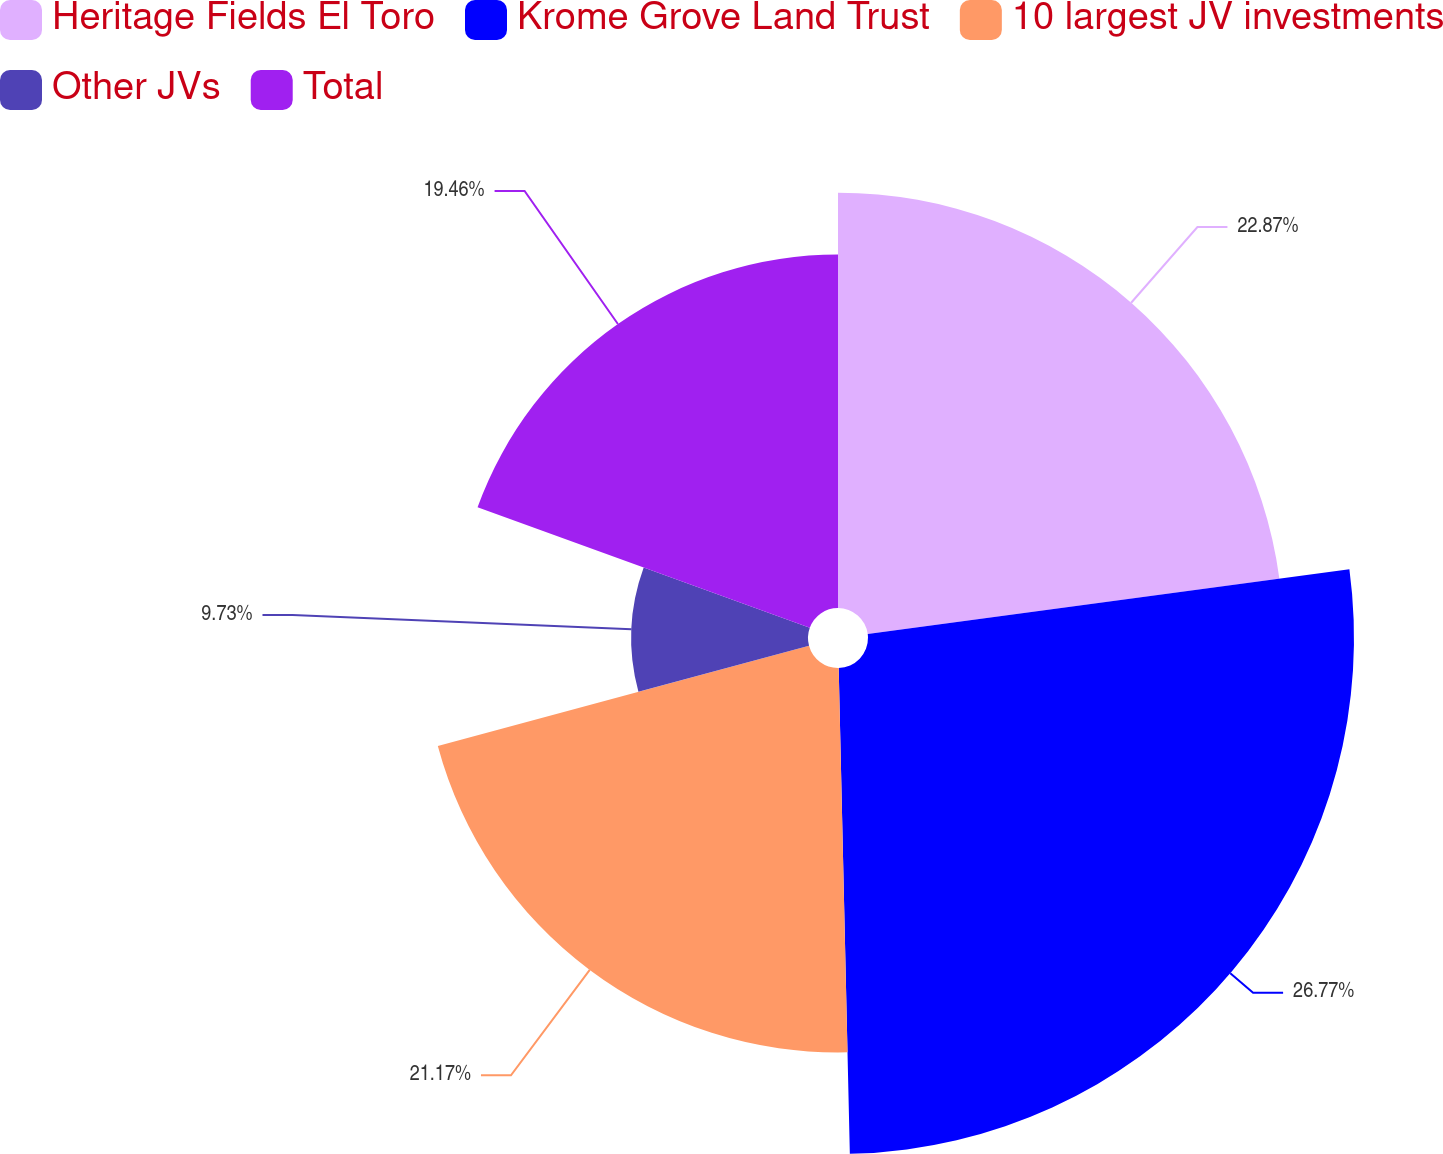Convert chart. <chart><loc_0><loc_0><loc_500><loc_500><pie_chart><fcel>Heritage Fields El Toro<fcel>Krome Grove Land Trust<fcel>10 largest JV investments<fcel>Other JVs<fcel>Total<nl><fcel>22.87%<fcel>26.76%<fcel>21.17%<fcel>9.73%<fcel>19.46%<nl></chart> 